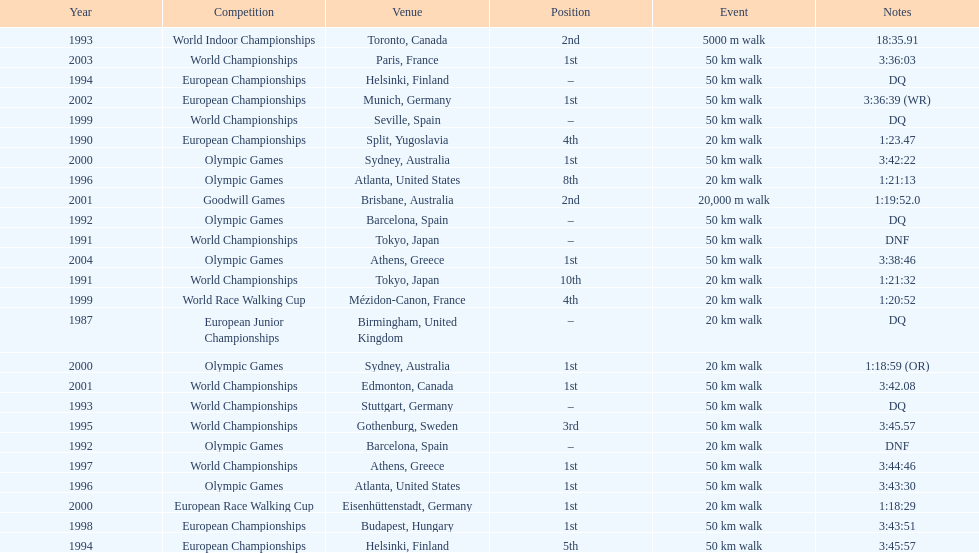How many times was korzeniowski disqualified from a competition? 5. 